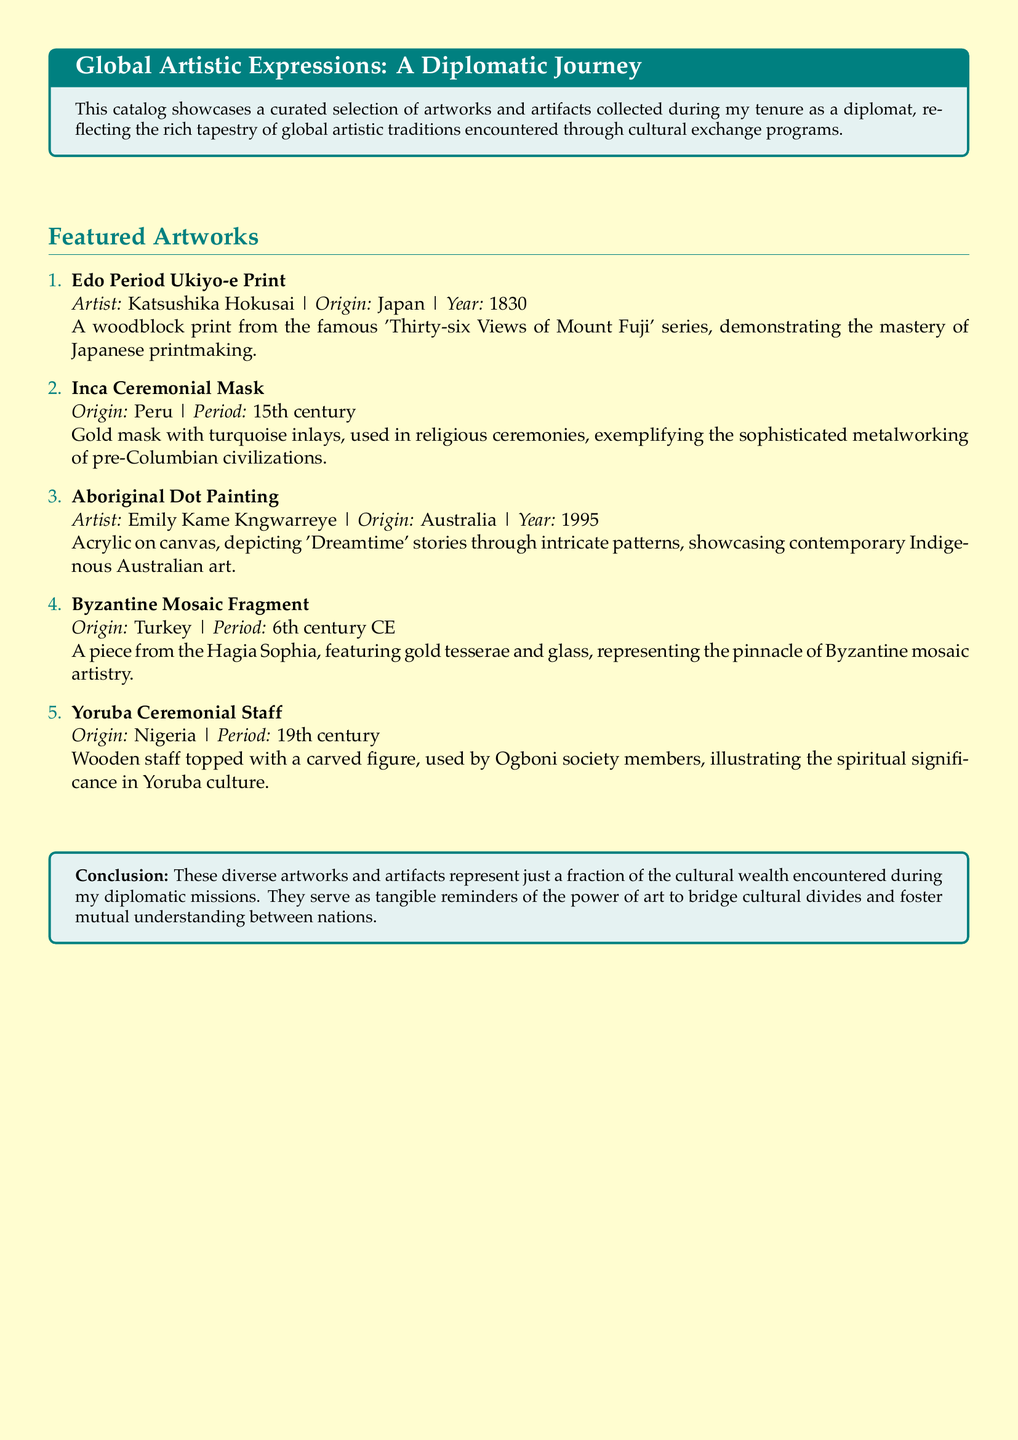What is the title of the catalog? The title of the catalog is prominently displayed at the top and is "Global Artistic Expressions: A Diplomatic Journey."
Answer: Global Artistic Expressions: A Diplomatic Journey Who is the artist of the Aboriginal Dot Painting? The artist's name is specified alongside the artwork's details in the catalog.
Answer: Emily Kame Kngwarreye In which year was the Edo Period Ukiyo-e Print created? The year of creation is given in the details of the artwork.
Answer: 1830 What material is the Yoruba Ceremonial Staff made of? The material used is mentioned in the description of the staff.
Answer: Wood From which period does the Inca Ceremonial Mask originate? The document specifies the historical period of the artifact.
Answer: 15th century What type of artistry does the Byzantine Mosaic Fragment represent? The nature of the artistry is explicitly described in its title.
Answer: Mosaic artistry How many featured artworks are listed in the catalog? The catalog enumerates the artworks under a numbered list.
Answer: Five What is the cultural significance of the Yoruba Ceremonial Staff? The catalog mentions the spiritual importance associated with the staff.
Answer: Spiritual significance What does the conclusion emphasize about the artworks? The conclusion highlights the role of art in fostering understanding between nations.
Answer: Power of art to bridge cultural divides 